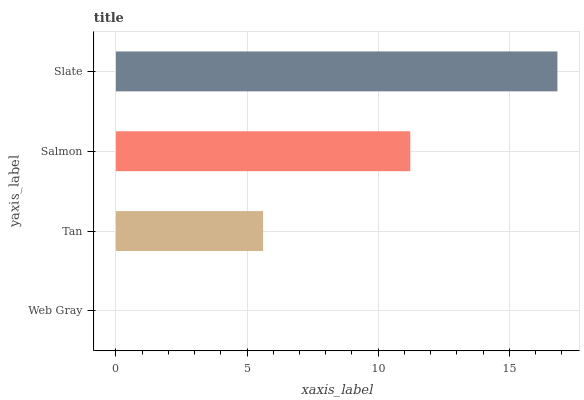Is Web Gray the minimum?
Answer yes or no. Yes. Is Slate the maximum?
Answer yes or no. Yes. Is Tan the minimum?
Answer yes or no. No. Is Tan the maximum?
Answer yes or no. No. Is Tan greater than Web Gray?
Answer yes or no. Yes. Is Web Gray less than Tan?
Answer yes or no. Yes. Is Web Gray greater than Tan?
Answer yes or no. No. Is Tan less than Web Gray?
Answer yes or no. No. Is Salmon the high median?
Answer yes or no. Yes. Is Tan the low median?
Answer yes or no. Yes. Is Tan the high median?
Answer yes or no. No. Is Web Gray the low median?
Answer yes or no. No. 